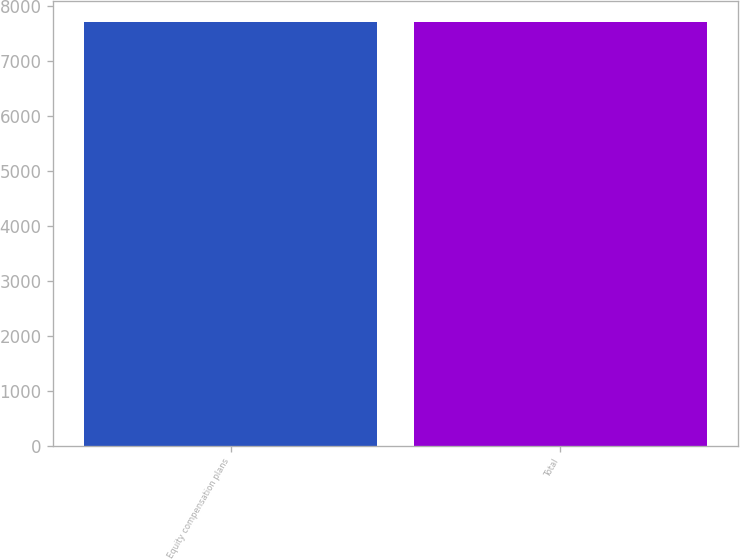Convert chart to OTSL. <chart><loc_0><loc_0><loc_500><loc_500><bar_chart><fcel>Equity compensation plans<fcel>Total<nl><fcel>7697<fcel>7697.1<nl></chart> 